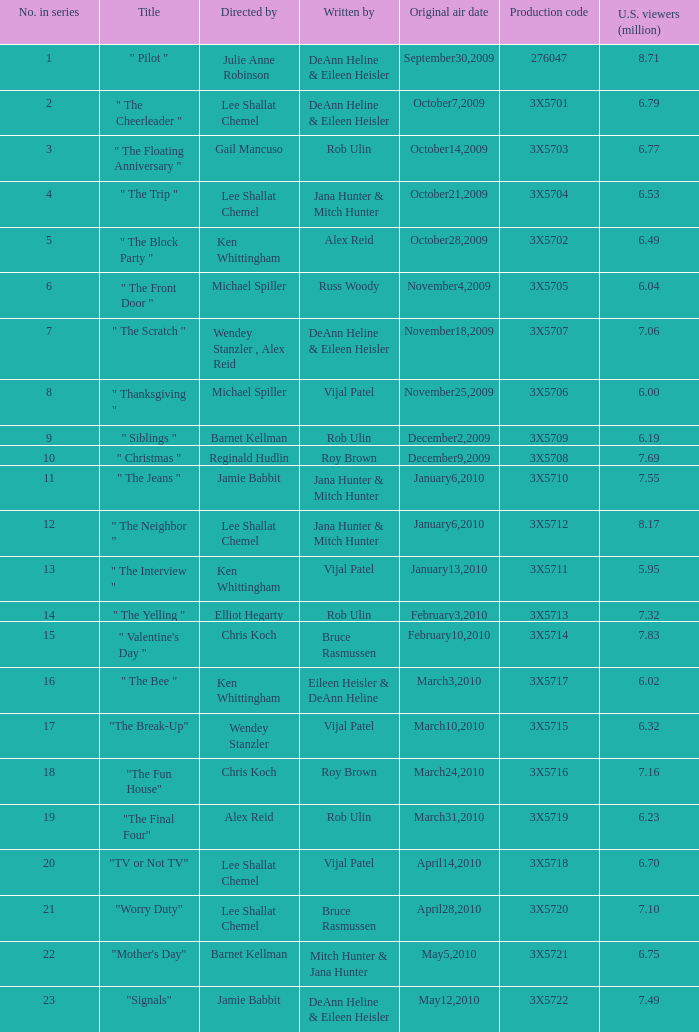Who wrote the episode that got 5.95 million U.S. viewers? Vijal Patel. 